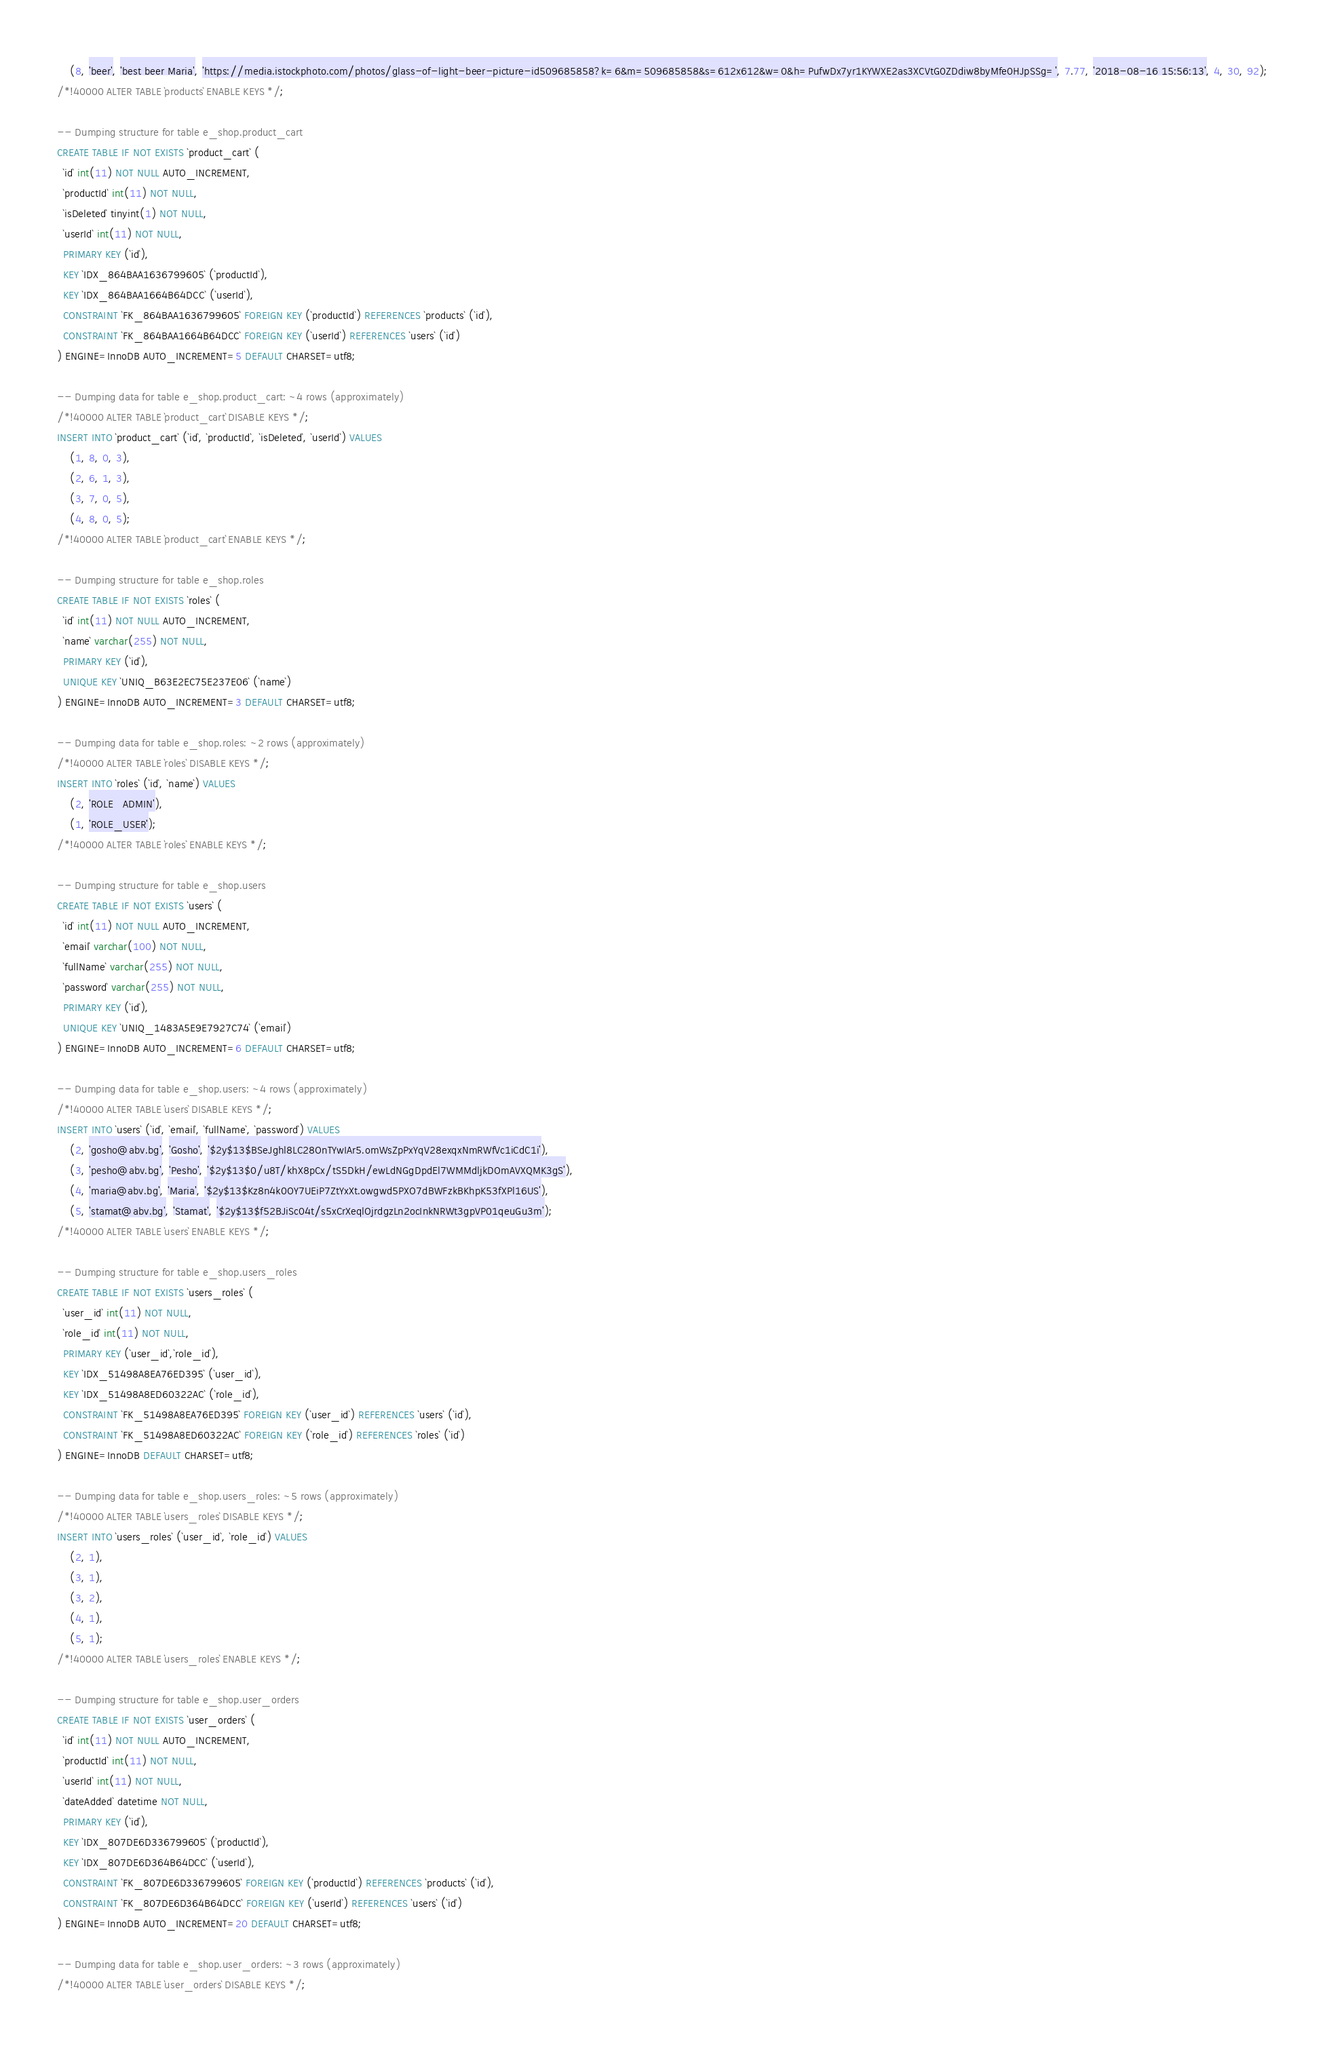Convert code to text. <code><loc_0><loc_0><loc_500><loc_500><_SQL_>	(8, 'beer', 'best beer Maria', 'https://media.istockphoto.com/photos/glass-of-light-beer-picture-id509685858?k=6&m=509685858&s=612x612&w=0&h=PufwDx7yr1KYWXE2as3XCVtG0ZDdiw8byMfe0HJpSSg=', 7.77, '2018-08-16 15:56:13', 4, 30, 92);
/*!40000 ALTER TABLE `products` ENABLE KEYS */;

-- Dumping structure for table e_shop.product_cart
CREATE TABLE IF NOT EXISTS `product_cart` (
  `id` int(11) NOT NULL AUTO_INCREMENT,
  `productId` int(11) NOT NULL,
  `isDeleted` tinyint(1) NOT NULL,
  `userId` int(11) NOT NULL,
  PRIMARY KEY (`id`),
  KEY `IDX_864BAA1636799605` (`productId`),
  KEY `IDX_864BAA1664B64DCC` (`userId`),
  CONSTRAINT `FK_864BAA1636799605` FOREIGN KEY (`productId`) REFERENCES `products` (`id`),
  CONSTRAINT `FK_864BAA1664B64DCC` FOREIGN KEY (`userId`) REFERENCES `users` (`id`)
) ENGINE=InnoDB AUTO_INCREMENT=5 DEFAULT CHARSET=utf8;

-- Dumping data for table e_shop.product_cart: ~4 rows (approximately)
/*!40000 ALTER TABLE `product_cart` DISABLE KEYS */;
INSERT INTO `product_cart` (`id`, `productId`, `isDeleted`, `userId`) VALUES
	(1, 8, 0, 3),
	(2, 6, 1, 3),
	(3, 7, 0, 5),
	(4, 8, 0, 5);
/*!40000 ALTER TABLE `product_cart` ENABLE KEYS */;

-- Dumping structure for table e_shop.roles
CREATE TABLE IF NOT EXISTS `roles` (
  `id` int(11) NOT NULL AUTO_INCREMENT,
  `name` varchar(255) NOT NULL,
  PRIMARY KEY (`id`),
  UNIQUE KEY `UNIQ_B63E2EC75E237E06` (`name`)
) ENGINE=InnoDB AUTO_INCREMENT=3 DEFAULT CHARSET=utf8;

-- Dumping data for table e_shop.roles: ~2 rows (approximately)
/*!40000 ALTER TABLE `roles` DISABLE KEYS */;
INSERT INTO `roles` (`id`, `name`) VALUES
	(2, 'ROLE_ADMIN'),
	(1, 'ROLE_USER');
/*!40000 ALTER TABLE `roles` ENABLE KEYS */;

-- Dumping structure for table e_shop.users
CREATE TABLE IF NOT EXISTS `users` (
  `id` int(11) NOT NULL AUTO_INCREMENT,
  `email` varchar(100) NOT NULL,
  `fullName` varchar(255) NOT NULL,
  `password` varchar(255) NOT NULL,
  PRIMARY KEY (`id`),
  UNIQUE KEY `UNIQ_1483A5E9E7927C74` (`email`)
) ENGINE=InnoDB AUTO_INCREMENT=6 DEFAULT CHARSET=utf8;

-- Dumping data for table e_shop.users: ~4 rows (approximately)
/*!40000 ALTER TABLE `users` DISABLE KEYS */;
INSERT INTO `users` (`id`, `email`, `fullName`, `password`) VALUES
	(2, 'gosho@abv.bg', 'Gosho', '$2y$13$BSeJghl8LC28OnTYwIAr5.omWsZpPxYqV28exqxNmRWfVc1iCdC1i'),
	(3, 'pesho@abv.bg', 'Pesho', '$2y$13$0/u8T/khX8pCx/tS5DkH/ewLdNGgDpdEl7WMMdljkDOmAVXQMK3gS'),
	(4, 'maria@abv.bg', 'Maria', '$2y$13$Kz8n4k0OY7UEiP7ZtYxXt.owgwd5PXO7dBWFzkBKhpK53fXPl16US'),
	(5, 'stamat@abv.bg', 'Stamat', '$2y$13$f52BJiSc04t/s5xCrXeqlOjrdgzLn2ocInkNRWt3gpVP01qeuGu3m');
/*!40000 ALTER TABLE `users` ENABLE KEYS */;

-- Dumping structure for table e_shop.users_roles
CREATE TABLE IF NOT EXISTS `users_roles` (
  `user_id` int(11) NOT NULL,
  `role_id` int(11) NOT NULL,
  PRIMARY KEY (`user_id`,`role_id`),
  KEY `IDX_51498A8EA76ED395` (`user_id`),
  KEY `IDX_51498A8ED60322AC` (`role_id`),
  CONSTRAINT `FK_51498A8EA76ED395` FOREIGN KEY (`user_id`) REFERENCES `users` (`id`),
  CONSTRAINT `FK_51498A8ED60322AC` FOREIGN KEY (`role_id`) REFERENCES `roles` (`id`)
) ENGINE=InnoDB DEFAULT CHARSET=utf8;

-- Dumping data for table e_shop.users_roles: ~5 rows (approximately)
/*!40000 ALTER TABLE `users_roles` DISABLE KEYS */;
INSERT INTO `users_roles` (`user_id`, `role_id`) VALUES
	(2, 1),
	(3, 1),
	(3, 2),
	(4, 1),
	(5, 1);
/*!40000 ALTER TABLE `users_roles` ENABLE KEYS */;

-- Dumping structure for table e_shop.user_orders
CREATE TABLE IF NOT EXISTS `user_orders` (
  `id` int(11) NOT NULL AUTO_INCREMENT,
  `productId` int(11) NOT NULL,
  `userId` int(11) NOT NULL,
  `dateAdded` datetime NOT NULL,
  PRIMARY KEY (`id`),
  KEY `IDX_807DE6D336799605` (`productId`),
  KEY `IDX_807DE6D364B64DCC` (`userId`),
  CONSTRAINT `FK_807DE6D336799605` FOREIGN KEY (`productId`) REFERENCES `products` (`id`),
  CONSTRAINT `FK_807DE6D364B64DCC` FOREIGN KEY (`userId`) REFERENCES `users` (`id`)
) ENGINE=InnoDB AUTO_INCREMENT=20 DEFAULT CHARSET=utf8;

-- Dumping data for table e_shop.user_orders: ~3 rows (approximately)
/*!40000 ALTER TABLE `user_orders` DISABLE KEYS */;</code> 